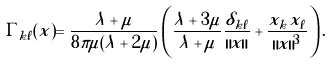Convert formula to latex. <formula><loc_0><loc_0><loc_500><loc_500>\Gamma _ { k \ell } ( x ) = \frac { \lambda + \mu } { 8 \pi \mu ( \lambda + 2 \mu ) } \left ( \frac { \lambda + 3 \mu } { \lambda + \mu } \frac { \delta _ { k \ell } } { \| x \| } + \frac { x _ { k } x _ { \ell } } { \| x \| ^ { 3 } } \right ) .</formula> 